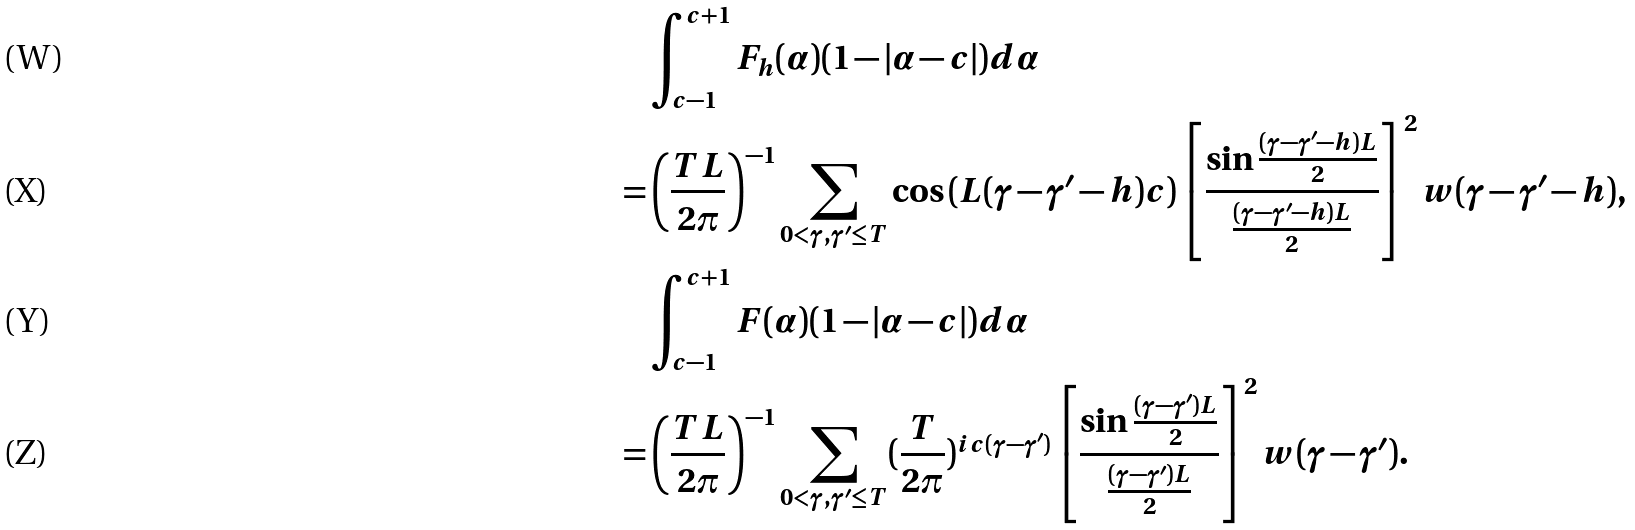Convert formula to latex. <formula><loc_0><loc_0><loc_500><loc_500>& \int _ { c - 1 } ^ { c + 1 } F _ { h } ( \alpha ) ( 1 - | \alpha - c | ) d \alpha \\ = & \left ( \frac { T L } { 2 \pi } \right ) ^ { - 1 } \sum _ { 0 < \gamma , \gamma ^ { \prime } \leq T } \cos { ( L ( \gamma - \gamma ^ { \prime } - h ) c ) } \left [ \frac { \sin { \frac { ( \gamma - \gamma ^ { \prime } - h ) L } { 2 } } } { \frac { ( \gamma - \gamma ^ { \prime } - h ) L } { 2 } } \right ] ^ { 2 } w ( \gamma - \gamma ^ { \prime } - h ) , \\ & \int _ { c - 1 } ^ { c + 1 } F ( \alpha ) ( 1 - | \alpha - c | ) d \alpha \\ = & \left ( \frac { T L } { 2 \pi } \right ) ^ { - 1 } \sum _ { 0 < \gamma , \gamma ^ { \prime } \leq T } ( \frac { T } { 2 \pi } ) ^ { i c ( \gamma - \gamma ^ { \prime } ) } \left [ \frac { \sin { \frac { ( \gamma - \gamma ^ { \prime } ) L } { 2 } } } { \frac { ( \gamma - \gamma ^ { \prime } ) L } { 2 } } \right ] ^ { 2 } w ( \gamma - \gamma ^ { \prime } ) .</formula> 